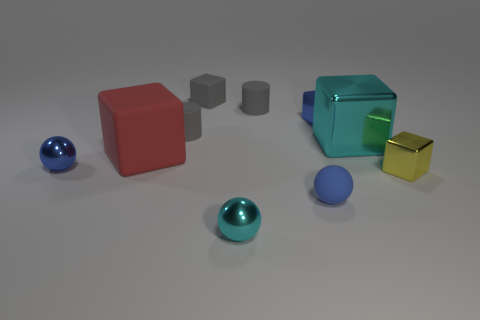Subtract 1 cubes. How many cubes are left? 4 Subtract all yellow shiny blocks. How many blocks are left? 4 Subtract all gray cubes. How many cubes are left? 4 Subtract all purple cubes. Subtract all green cylinders. How many cubes are left? 5 Subtract all cylinders. How many objects are left? 8 Subtract 0 brown cubes. How many objects are left? 10 Subtract all big cyan rubber objects. Subtract all rubber blocks. How many objects are left? 8 Add 5 tiny shiny objects. How many tiny shiny objects are left? 9 Add 5 tiny cyan objects. How many tiny cyan objects exist? 6 